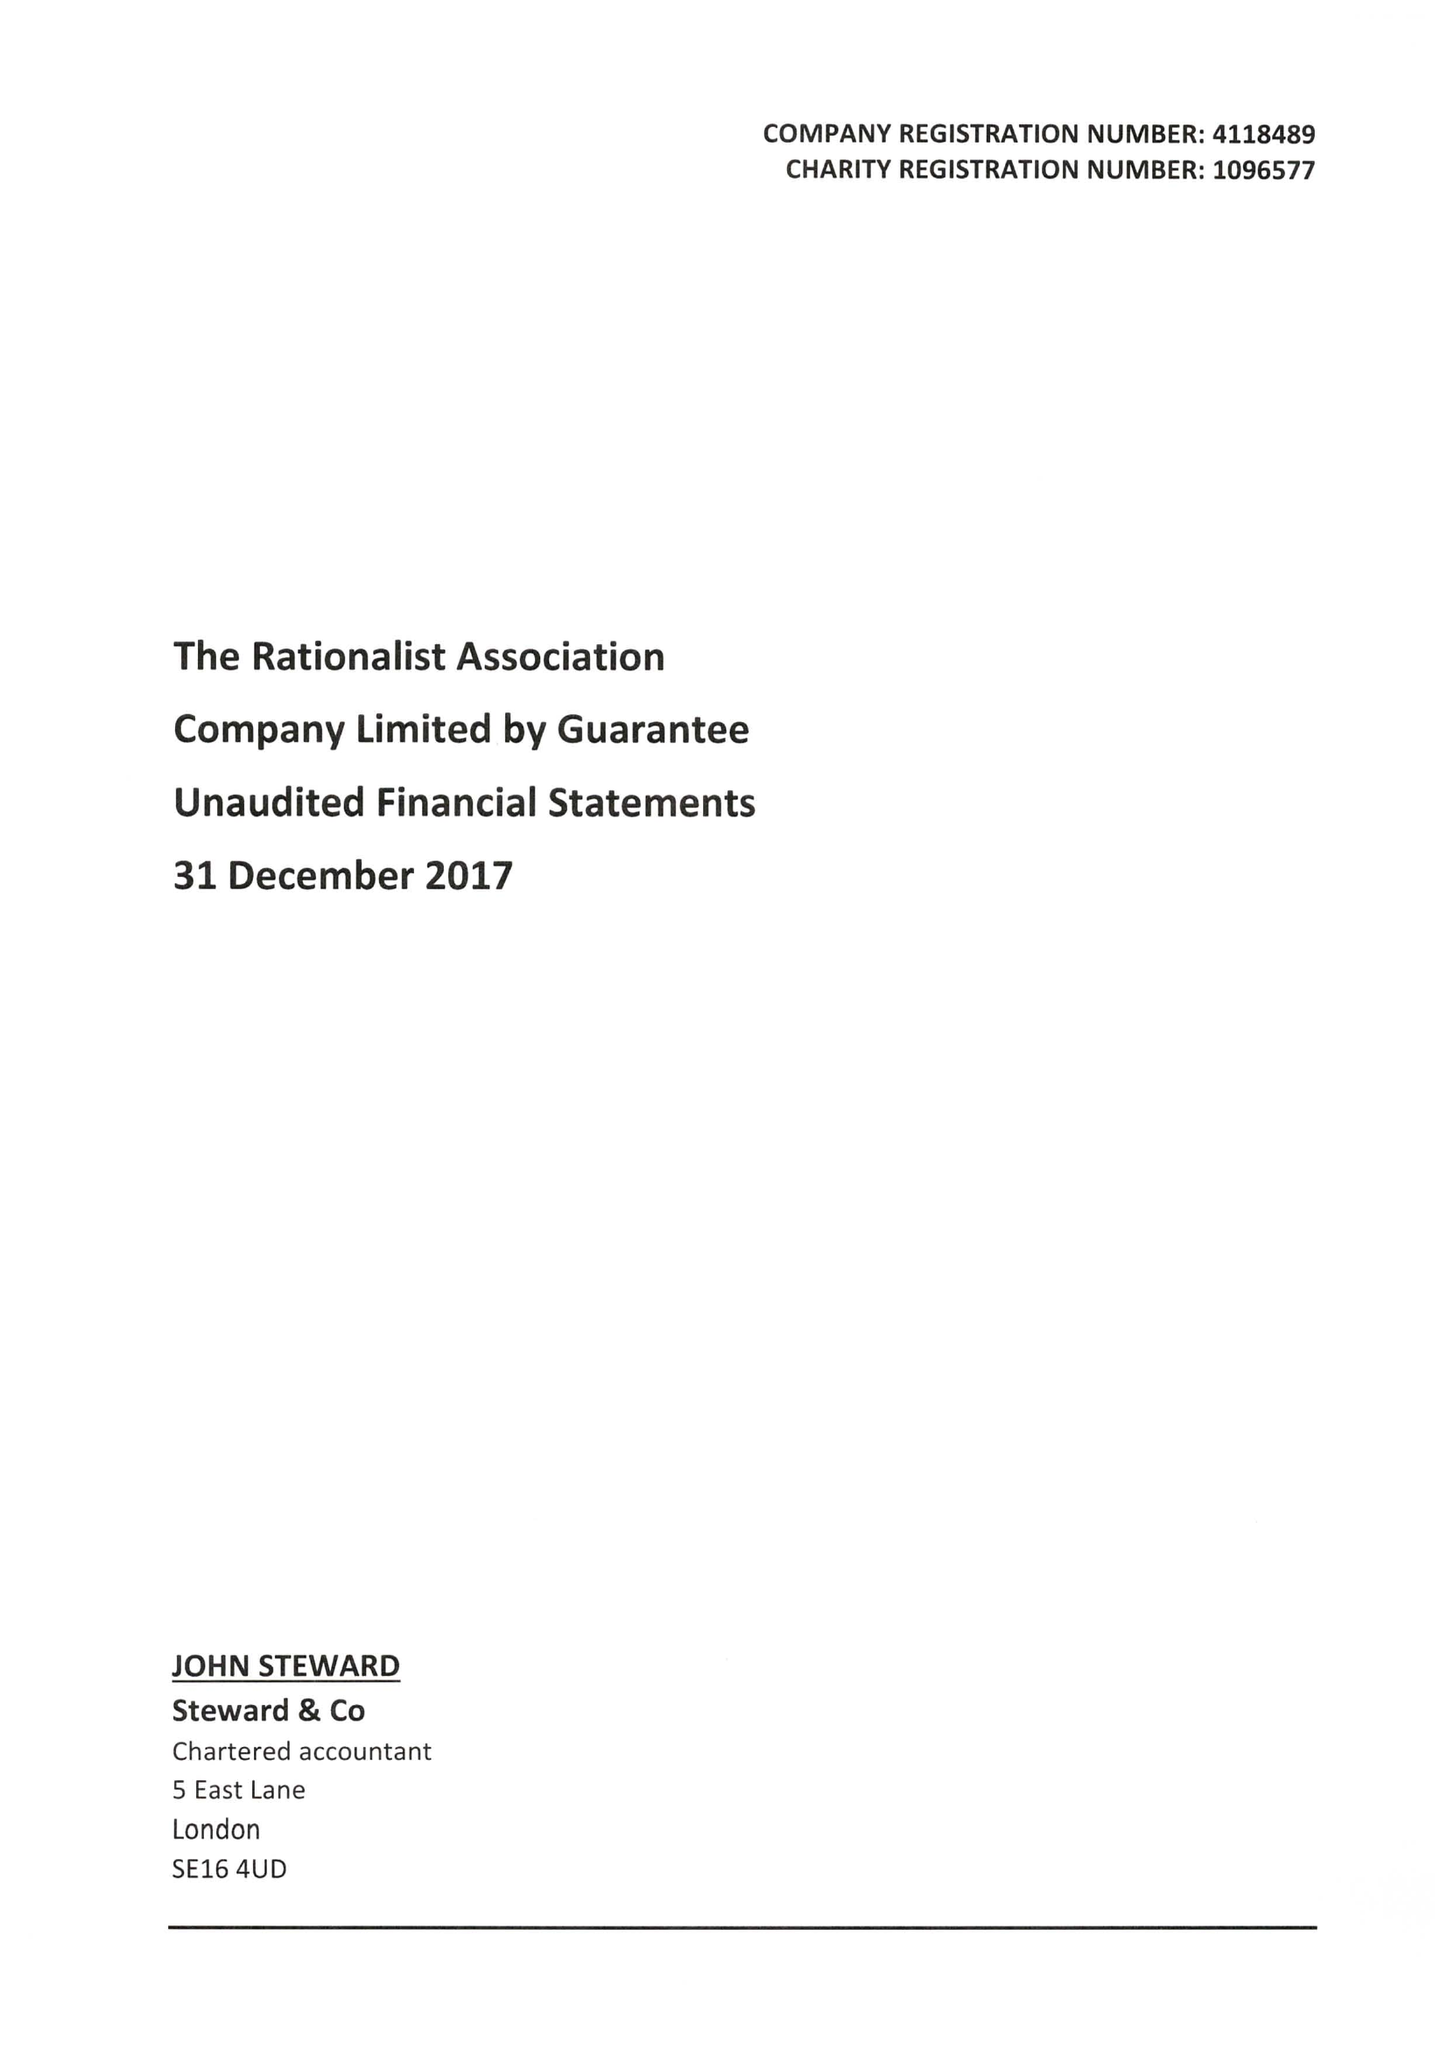What is the value for the address__street_line?
Answer the question using a single word or phrase. 244-254 CAMBRIDGE HEATH ROAD 